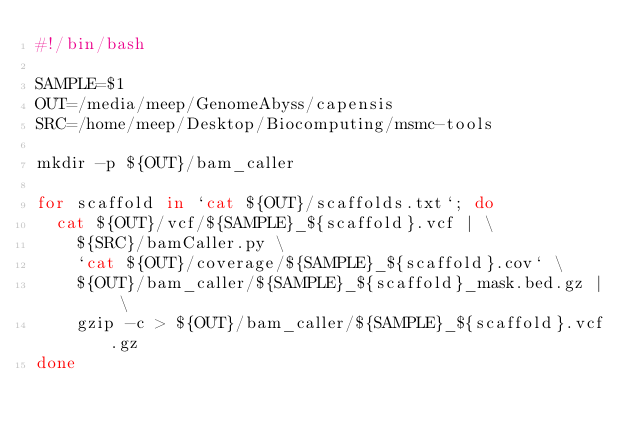<code> <loc_0><loc_0><loc_500><loc_500><_Bash_>#!/bin/bash

SAMPLE=$1
OUT=/media/meep/GenomeAbyss/capensis
SRC=/home/meep/Desktop/Biocomputing/msmc-tools

mkdir -p ${OUT}/bam_caller

for scaffold in `cat ${OUT}/scaffolds.txt`; do
	cat ${OUT}/vcf/${SAMPLE}_${scaffold}.vcf | \
		${SRC}/bamCaller.py \
		`cat ${OUT}/coverage/${SAMPLE}_${scaffold}.cov` \
		${OUT}/bam_caller/${SAMPLE}_${scaffold}_mask.bed.gz | \
		gzip -c > ${OUT}/bam_caller/${SAMPLE}_${scaffold}.vcf.gz
done
</code> 